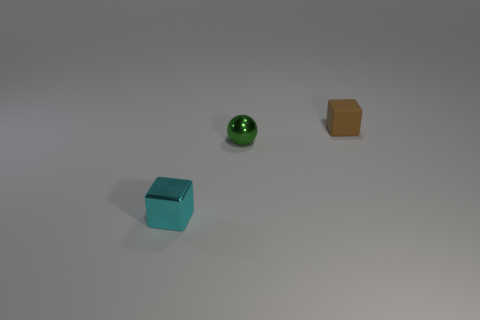What are the objects made of in this image? The objects appear to be made of different materials; the leftmost block looks metallic, the middle object seems to be a glossy ceramic or plastic, while the rightmost block appears to be matte, possibly made of paper or cardboard.  Could you tell me the shapes of these objects? Certainly! The image shows three objects with distinct shapes: the one on the left is a cube, the center object is a sphere, and the object on the right is a cuboid or rectangular prism. 